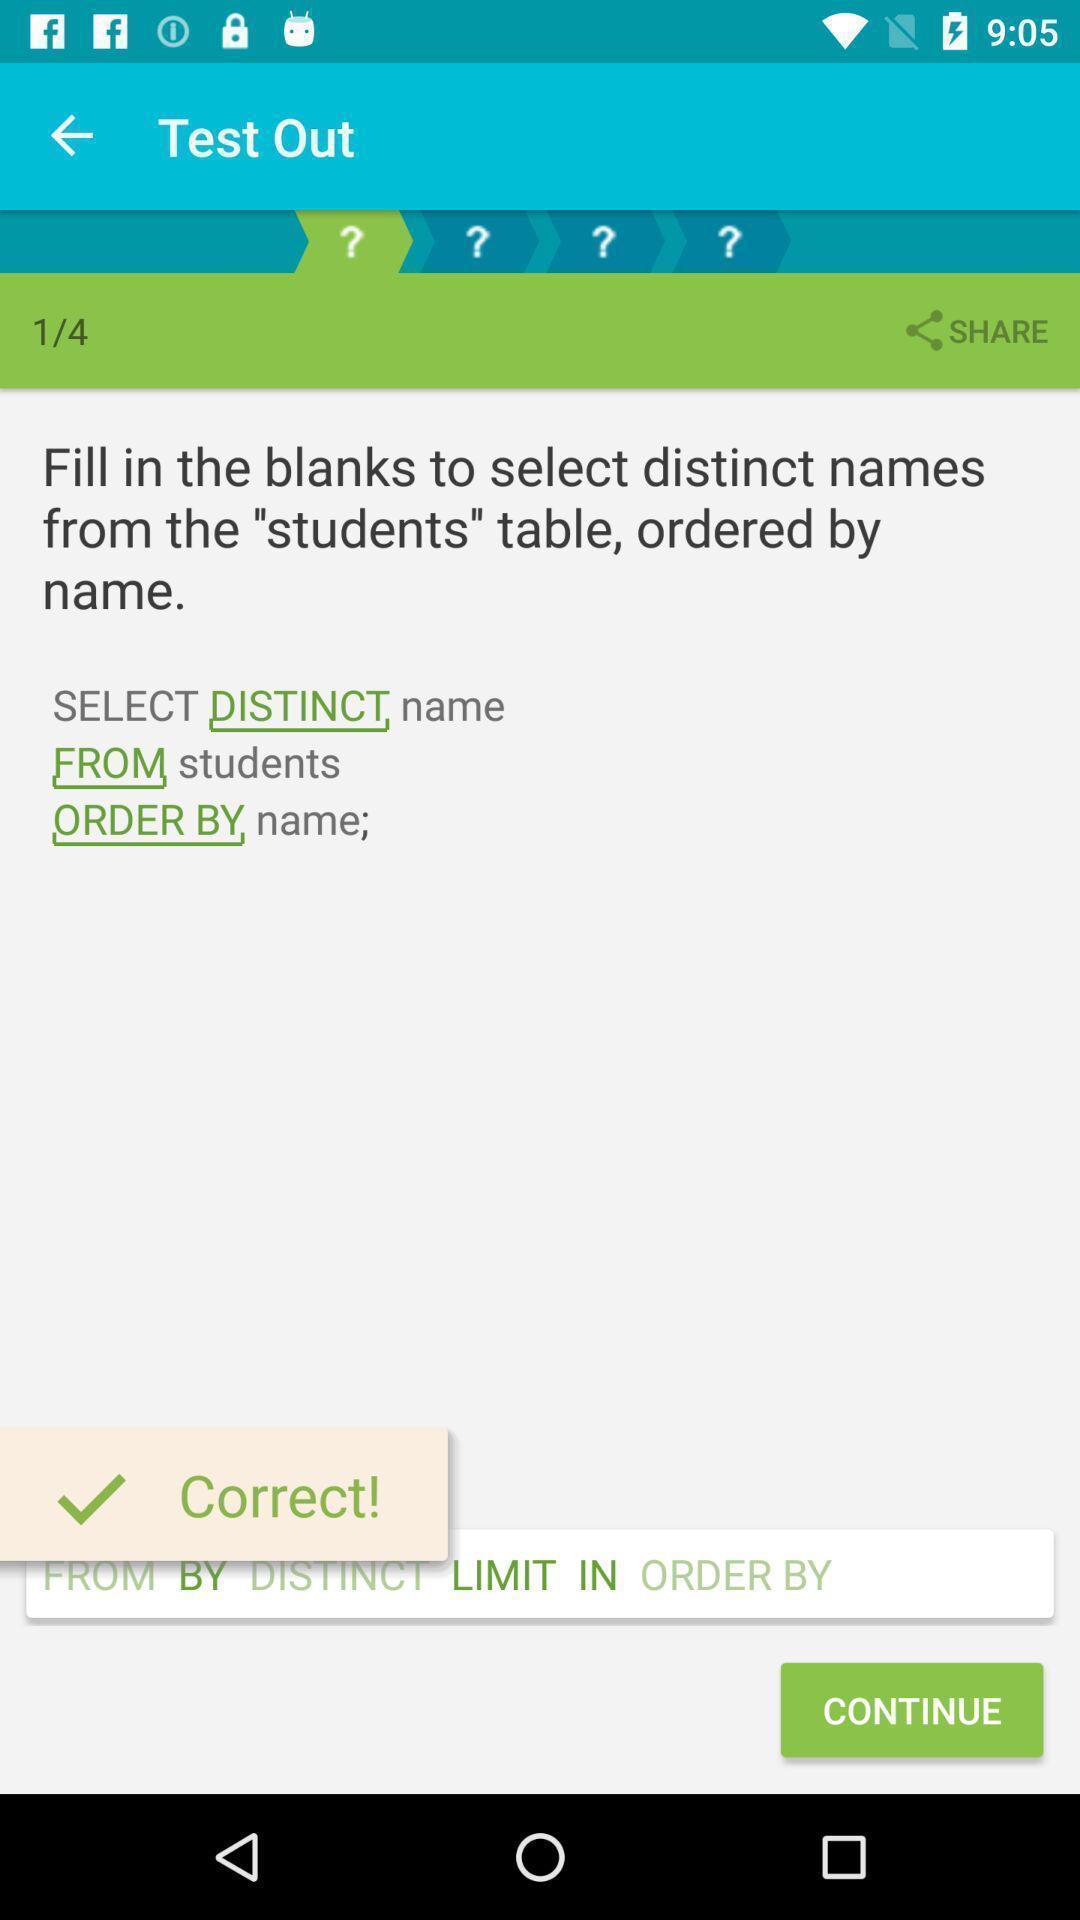Explain what's happening in this screen capture. Page displaying test for sql of a learning app. 